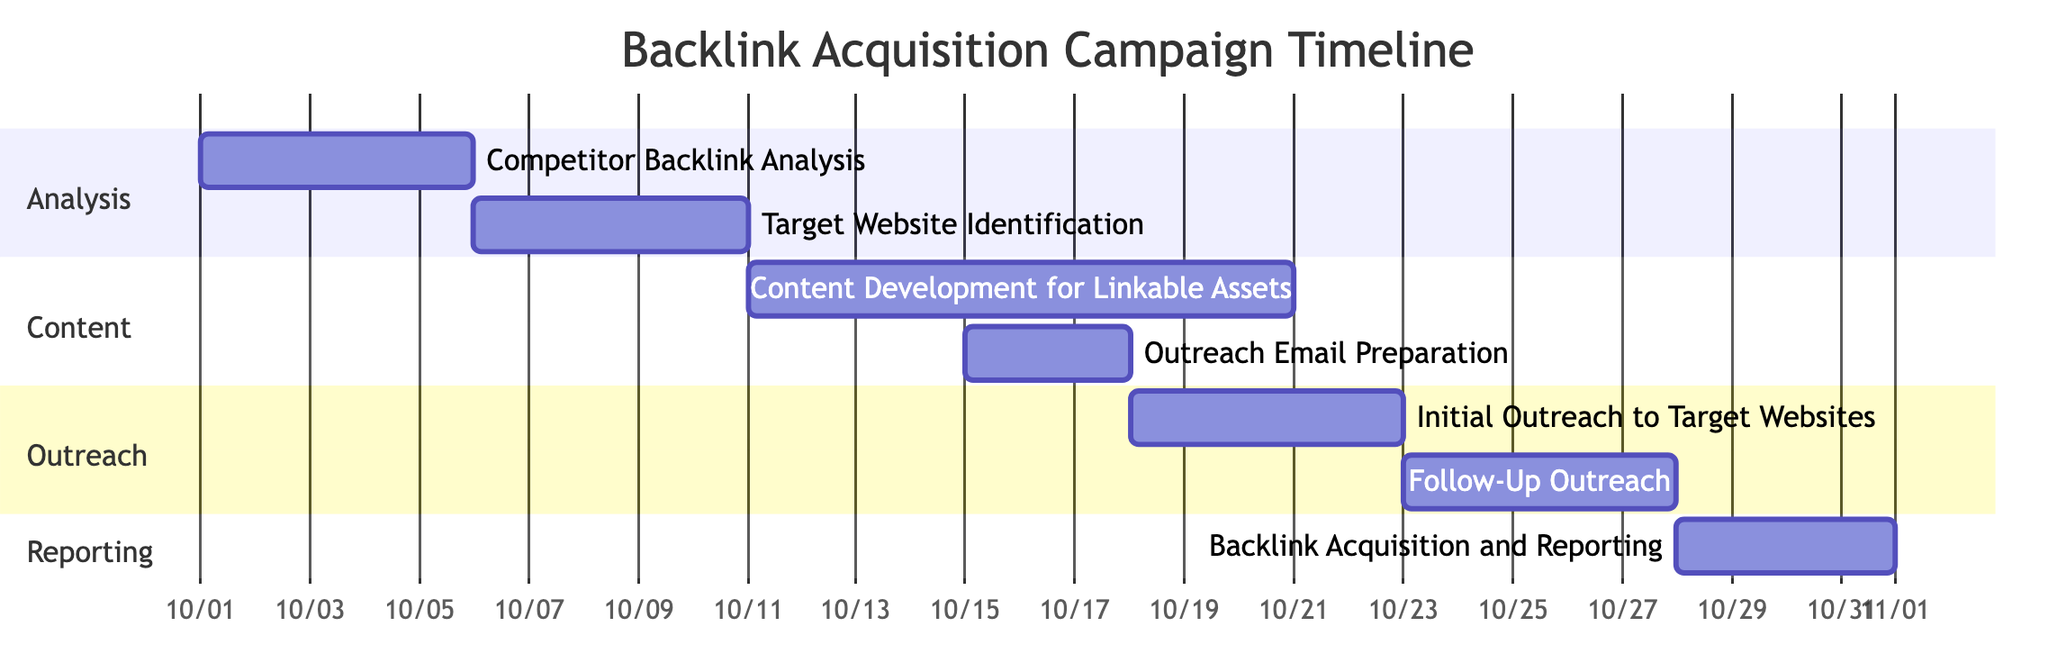What is the duration of the "Competitor Backlink Analysis"? The "Competitor Backlink Analysis" starts on October 1, 2023, and ends on October 5, 2023, which gives a duration of 5 days.
Answer: 5 days What task follows "Initial Outreach to Target Websites"? The task that follows "Initial Outreach to Target Websites" is "Follow-Up Outreach", which starts on October 23, 2023.
Answer: Follow-Up Outreach How many tasks are in the "Outreach" section? In the "Outreach" section, there are two tasks: "Initial Outreach to Target Websites" and "Follow-Up Outreach". Thus, the number is 2.
Answer: 2 What is the earliest start date of the campaign? The earliest start date in the campaign is October 1, 2023, marked by the beginning of "Competitor Backlink Analysis".
Answer: October 1, 2023 Which task is dependent on "Outreach Email Preparation"? The task that is dependent on "Outreach Email Preparation" is "Initial Outreach to Target Websites", which follows it directly in the timeline.
Answer: Initial Outreach to Target Websites How long is the "Backlink Acquisition and Reporting"? "Backlink Acquisition and Reporting" has a duration of 4 days, starting on October 28, 2023, and ending on October 31, 2023.
Answer: 4 days Which section contains the most tasks? The section with the most tasks is "Content", which contains two tasks: "Content Development for Linkable Assets" and "Outreach Email Preparation".
Answer: Content What is the relationship between "Target Website Identification" and "Content Development for Linkable Assets"? "Content Development for Linkable Assets" depends on the completion of "Target Website Identification", indicating that it cannot start until the prior task is finished.
Answer: Dependent relationship What dates does "Follow-Up Outreach" cover? "Follow-Up Outreach" covers from October 23, 2023, to October 27, 2023, making it a 5-day period.
Answer: October 23 to October 27, 2023 